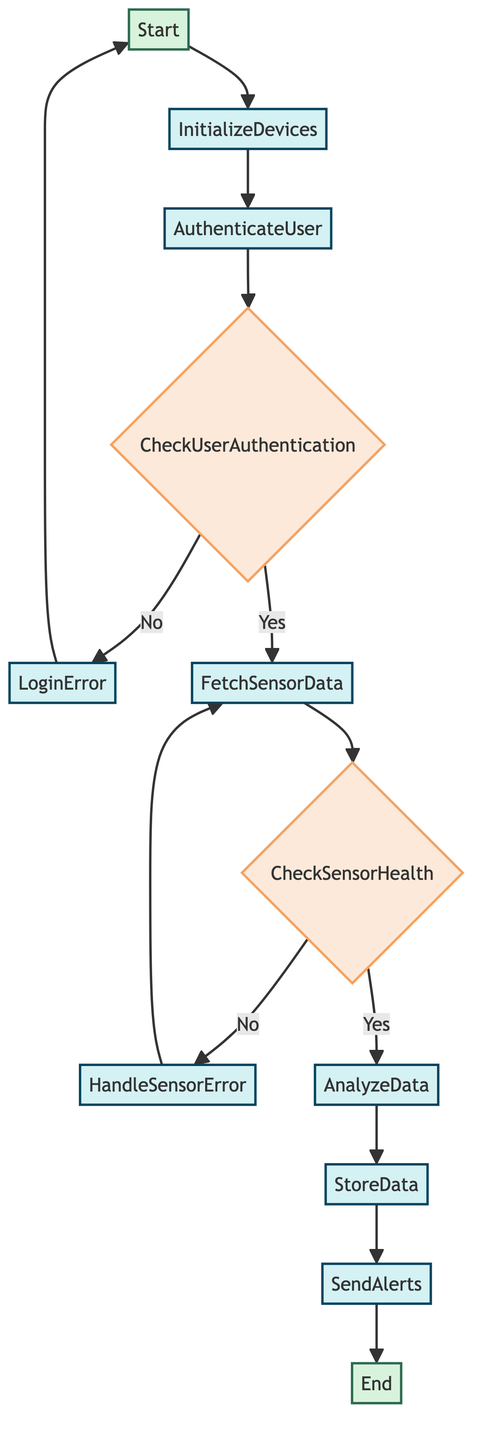What is the starting point of the function? The starting point is labeled as "Start" in the diagram, indicating where the function begins execution.
Answer: Start How many decision nodes are present in the diagram? The diagram contains two decision nodes, "CheckUserAuthentication" and "CheckSensorHealth".
Answer: 2 What process follows after successful user authentication? After successful user authentication, the process that follows is "FetchSensorData".
Answer: FetchSensorData Which process handles login errors? The process responsible for handling login errors is "LoginError".
Answer: LoginError What happens if sensor data is invalid? If the sensor data is invalid, the function moves to "HandleSensorError".
Answer: HandleSensorError What is the output of the function? The output of the function is indicated as reaching the "End" node.
Answer: End If user authentication fails, where does the flowchart lead next? If user authentication fails, the flow leads to "LoginError", and then back to "Start".
Answer: LoginError What process analyzes the fetched sensor data? The process that analyzes the fetched sensor data is "AnalyzeData".
Answer: AnalyzeData Which process stores the analyzed health data? The process responsible for storing the analyzed health data is "StoreData".
Answer: StoreData 